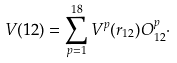Convert formula to latex. <formula><loc_0><loc_0><loc_500><loc_500>V ( 1 2 ) = \sum _ { p = 1 } ^ { 1 8 } V ^ { p } ( r _ { 1 2 } ) O ^ { p } _ { 1 2 } \cdot</formula> 